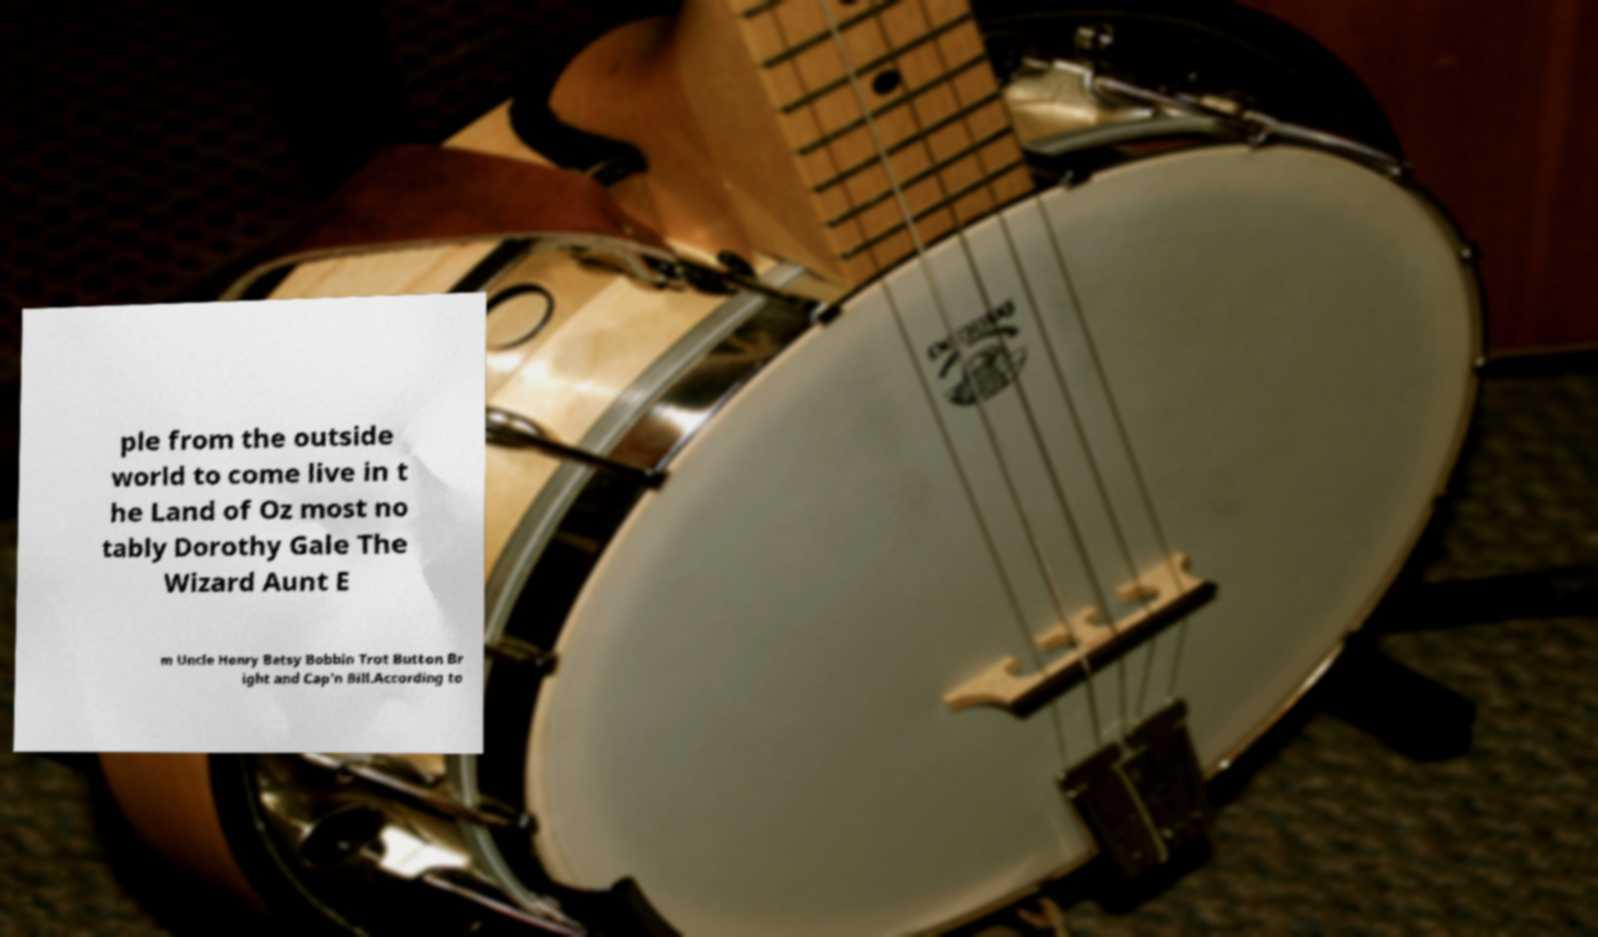I need the written content from this picture converted into text. Can you do that? ple from the outside world to come live in t he Land of Oz most no tably Dorothy Gale The Wizard Aunt E m Uncle Henry Betsy Bobbin Trot Button Br ight and Cap'n Bill.According to 